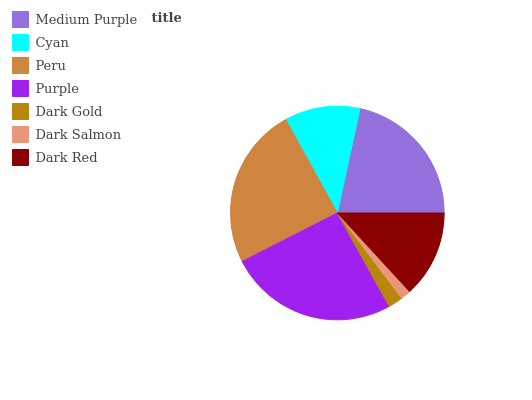Is Dark Salmon the minimum?
Answer yes or no. Yes. Is Purple the maximum?
Answer yes or no. Yes. Is Cyan the minimum?
Answer yes or no. No. Is Cyan the maximum?
Answer yes or no. No. Is Medium Purple greater than Cyan?
Answer yes or no. Yes. Is Cyan less than Medium Purple?
Answer yes or no. Yes. Is Cyan greater than Medium Purple?
Answer yes or no. No. Is Medium Purple less than Cyan?
Answer yes or no. No. Is Dark Red the high median?
Answer yes or no. Yes. Is Dark Red the low median?
Answer yes or no. Yes. Is Dark Salmon the high median?
Answer yes or no. No. Is Dark Salmon the low median?
Answer yes or no. No. 